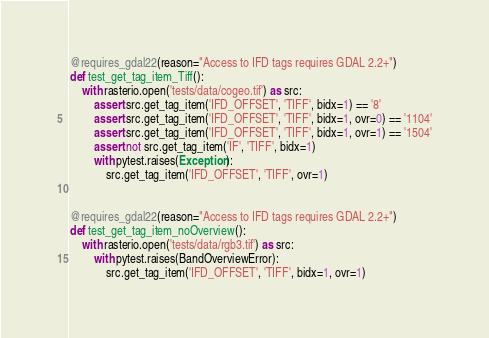Convert code to text. <code><loc_0><loc_0><loc_500><loc_500><_Python_>@requires_gdal22(reason="Access to IFD tags requires GDAL 2.2+")
def test_get_tag_item_Tiff():
    with rasterio.open('tests/data/cogeo.tif') as src:
        assert src.get_tag_item('IFD_OFFSET', 'TIFF', bidx=1) == '8'
        assert src.get_tag_item('IFD_OFFSET', 'TIFF', bidx=1, ovr=0) == '1104'
        assert src.get_tag_item('IFD_OFFSET', 'TIFF', bidx=1, ovr=1) == '1504'
        assert not src.get_tag_item('IF', 'TIFF', bidx=1)
        with pytest.raises(Exception):
            src.get_tag_item('IFD_OFFSET', 'TIFF', ovr=1)


@requires_gdal22(reason="Access to IFD tags requires GDAL 2.2+")
def test_get_tag_item_noOverview():
    with rasterio.open('tests/data/rgb3.tif') as src:
        with pytest.raises(BandOverviewError):
            src.get_tag_item('IFD_OFFSET', 'TIFF', bidx=1, ovr=1)
</code> 